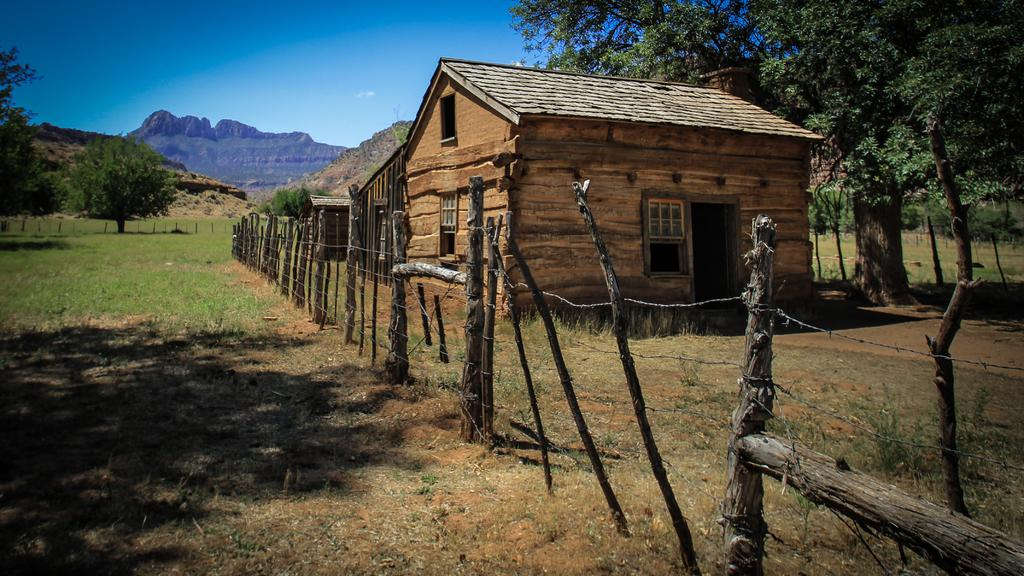What type of vegetation is present in the image? There is grass in the image. What structure can be seen surrounding the grassy area? There is a fence in the image. What type of building is visible in the image? There is a house in the image. What architectural feature can be seen on the house? There are windows in the image. What other natural elements are present in the image? There are trees in the image. What can be seen in the distance in the background of the image? In the background, there are hills visible. What part of the natural environment is visible in the background of the image? The sky is visible in the background of the image. What type of pipe can be seen in the image? There is no pipe present in the image. 